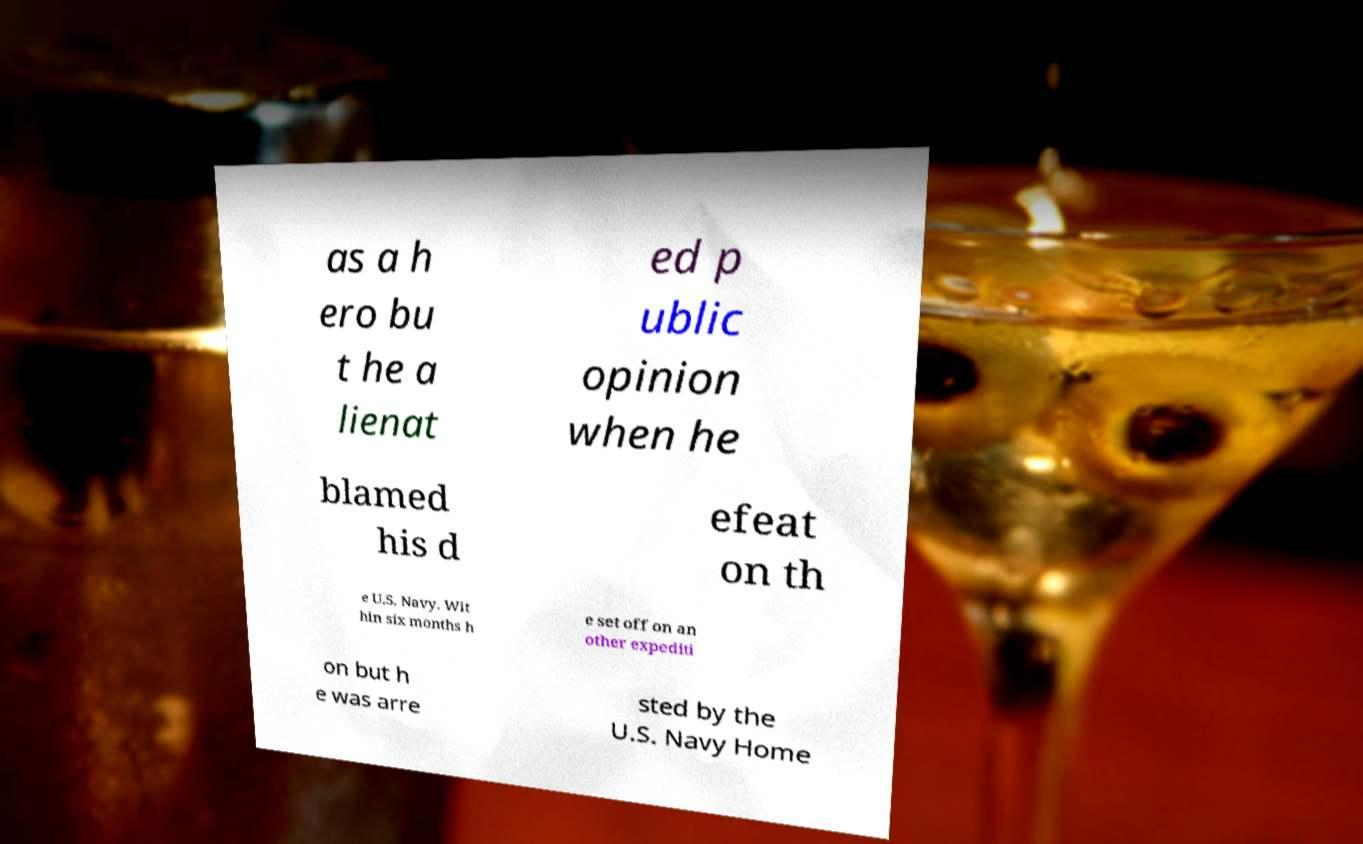Please identify and transcribe the text found in this image. as a h ero bu t he a lienat ed p ublic opinion when he blamed his d efeat on th e U.S. Navy. Wit hin six months h e set off on an other expediti on but h e was arre sted by the U.S. Navy Home 